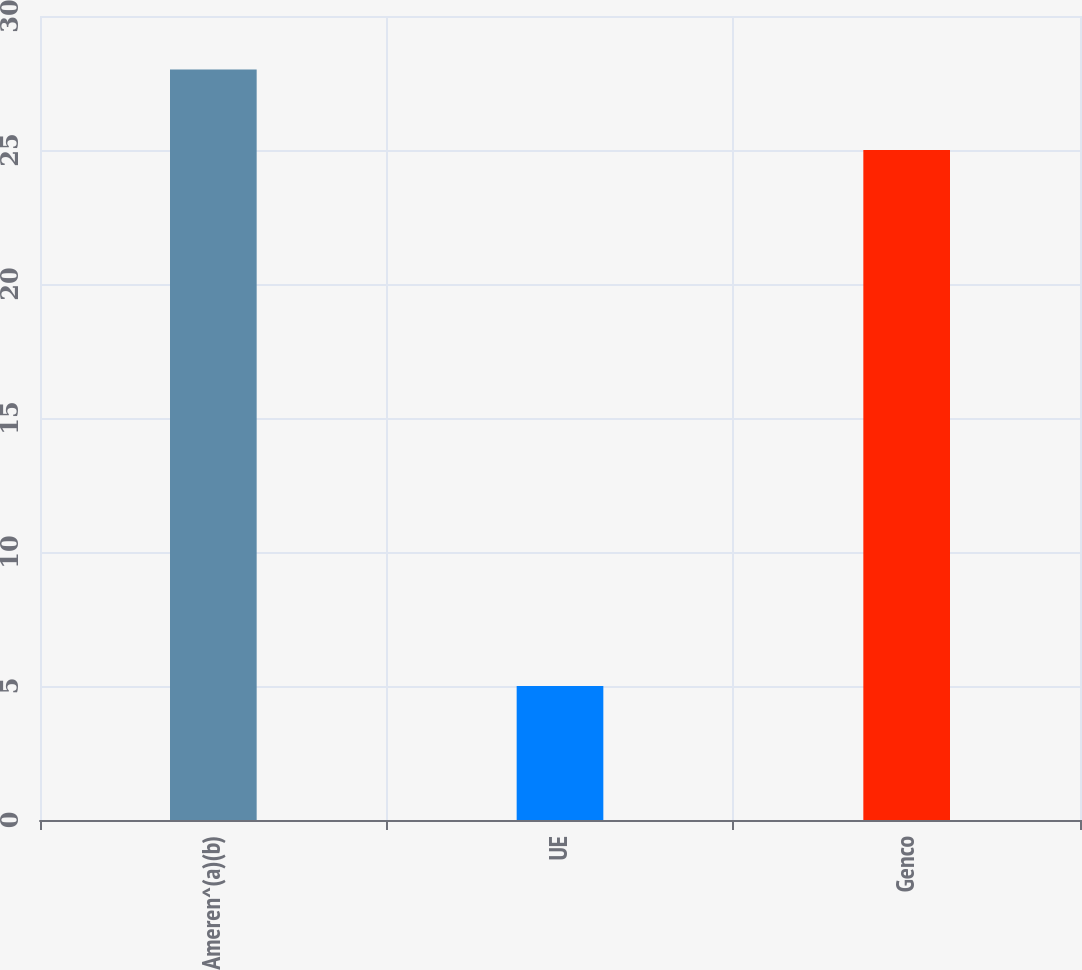Convert chart. <chart><loc_0><loc_0><loc_500><loc_500><bar_chart><fcel>Ameren^(a)(b)<fcel>UE<fcel>Genco<nl><fcel>28<fcel>5<fcel>25<nl></chart> 